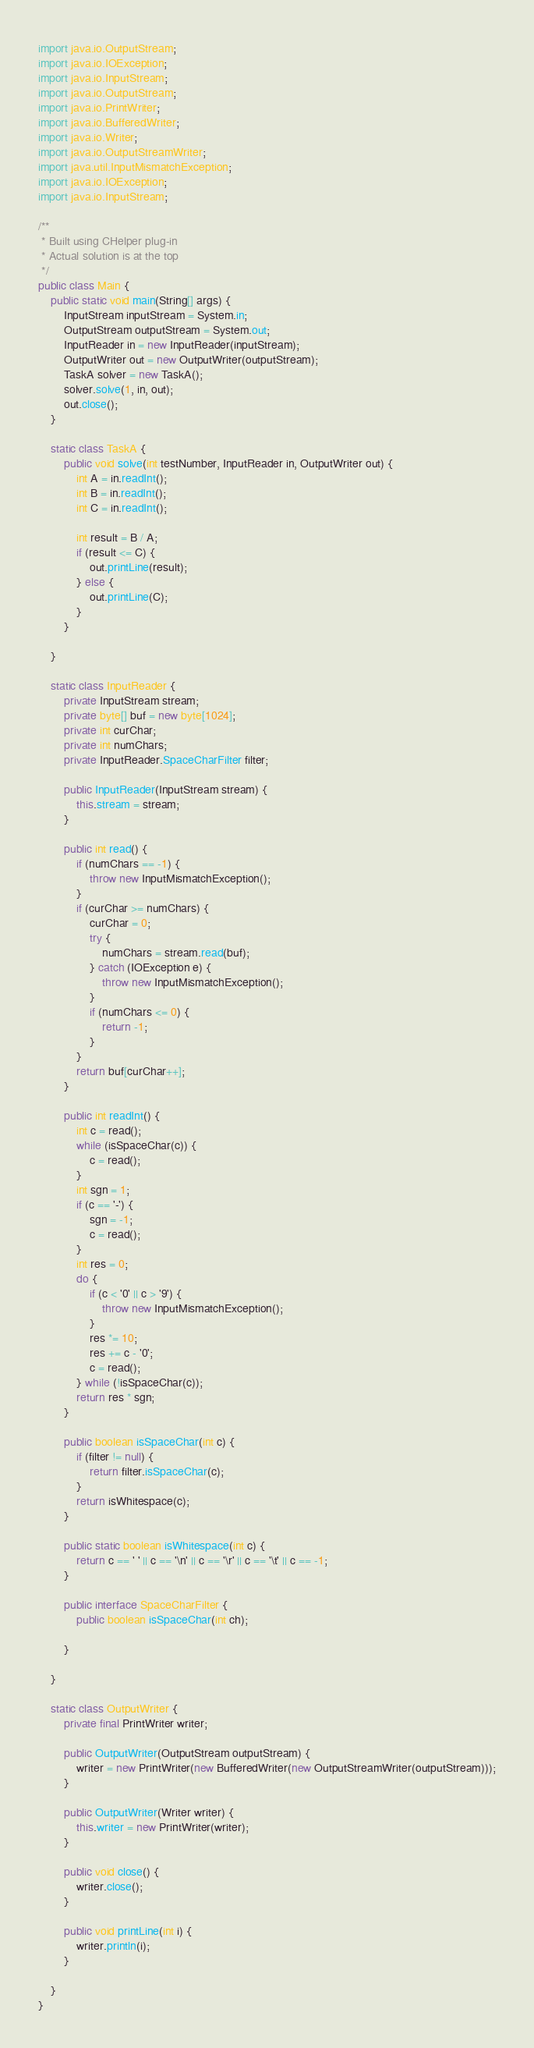<code> <loc_0><loc_0><loc_500><loc_500><_Java_>import java.io.OutputStream;
import java.io.IOException;
import java.io.InputStream;
import java.io.OutputStream;
import java.io.PrintWriter;
import java.io.BufferedWriter;
import java.io.Writer;
import java.io.OutputStreamWriter;
import java.util.InputMismatchException;
import java.io.IOException;
import java.io.InputStream;

/**
 * Built using CHelper plug-in
 * Actual solution is at the top
 */
public class Main {
    public static void main(String[] args) {
        InputStream inputStream = System.in;
        OutputStream outputStream = System.out;
        InputReader in = new InputReader(inputStream);
        OutputWriter out = new OutputWriter(outputStream);
        TaskA solver = new TaskA();
        solver.solve(1, in, out);
        out.close();
    }

    static class TaskA {
        public void solve(int testNumber, InputReader in, OutputWriter out) {
            int A = in.readInt();
            int B = in.readInt();
            int C = in.readInt();

            int result = B / A;
            if (result <= C) {
                out.printLine(result);
            } else {
                out.printLine(C);
            }
        }

    }

    static class InputReader {
        private InputStream stream;
        private byte[] buf = new byte[1024];
        private int curChar;
        private int numChars;
        private InputReader.SpaceCharFilter filter;

        public InputReader(InputStream stream) {
            this.stream = stream;
        }

        public int read() {
            if (numChars == -1) {
                throw new InputMismatchException();
            }
            if (curChar >= numChars) {
                curChar = 0;
                try {
                    numChars = stream.read(buf);
                } catch (IOException e) {
                    throw new InputMismatchException();
                }
                if (numChars <= 0) {
                    return -1;
                }
            }
            return buf[curChar++];
        }

        public int readInt() {
            int c = read();
            while (isSpaceChar(c)) {
                c = read();
            }
            int sgn = 1;
            if (c == '-') {
                sgn = -1;
                c = read();
            }
            int res = 0;
            do {
                if (c < '0' || c > '9') {
                    throw new InputMismatchException();
                }
                res *= 10;
                res += c - '0';
                c = read();
            } while (!isSpaceChar(c));
            return res * sgn;
        }

        public boolean isSpaceChar(int c) {
            if (filter != null) {
                return filter.isSpaceChar(c);
            }
            return isWhitespace(c);
        }

        public static boolean isWhitespace(int c) {
            return c == ' ' || c == '\n' || c == '\r' || c == '\t' || c == -1;
        }

        public interface SpaceCharFilter {
            public boolean isSpaceChar(int ch);

        }

    }

    static class OutputWriter {
        private final PrintWriter writer;

        public OutputWriter(OutputStream outputStream) {
            writer = new PrintWriter(new BufferedWriter(new OutputStreamWriter(outputStream)));
        }

        public OutputWriter(Writer writer) {
            this.writer = new PrintWriter(writer);
        }

        public void close() {
            writer.close();
        }

        public void printLine(int i) {
            writer.println(i);
        }

    }
}

</code> 